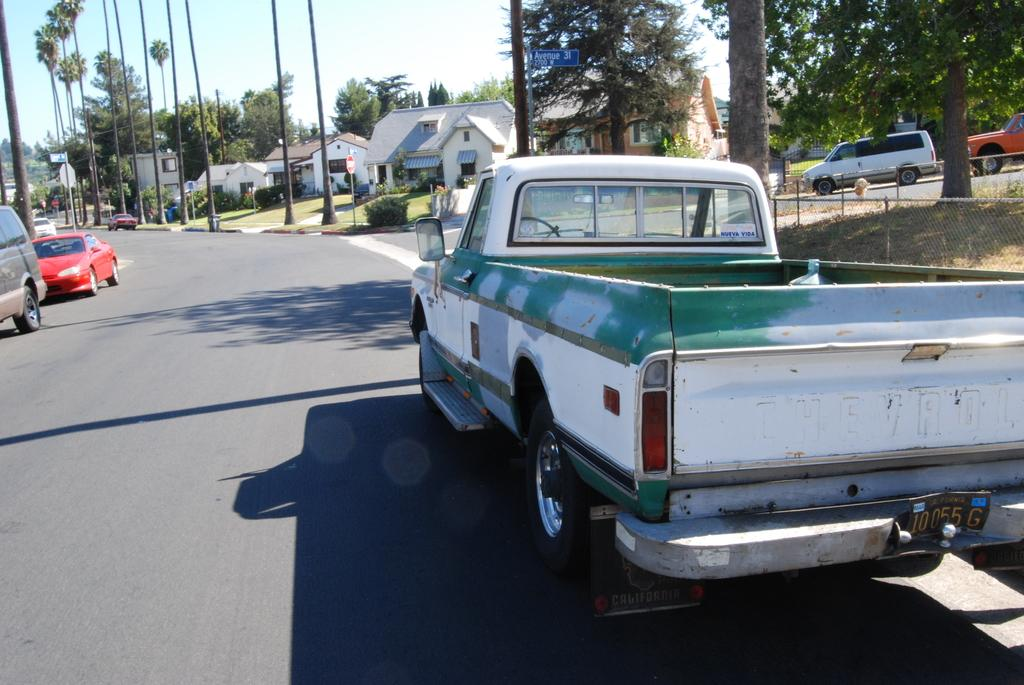What types of objects can be seen in the image? There are vehicles, trees, plants, grass, houses, and a road in the image. What can be found in the background of the image? The sky is visible in the background of the image. What type of vegetation is present in the image? There are trees and plants in the image. What might be used for transportation in the image? The vehicles in the image can be used for transportation. What type of meat can be seen hanging from the trees in the image? There is no meat present in the image; it features trees, plants, grass, houses, vehicles, and a road. What type of baseball equipment can be seen in the image? There is no baseball equipment present in the image. 